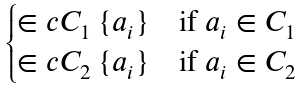Convert formula to latex. <formula><loc_0><loc_0><loc_500><loc_500>\begin{cases} \in c { C _ { 1 } \ \{ a _ { i } \} } & \text {if } a _ { i } \in C _ { 1 } \\ \in c { C _ { 2 } \ \{ a _ { i } \} } & \text {if } a _ { i } \in C _ { 2 } \end{cases}</formula> 